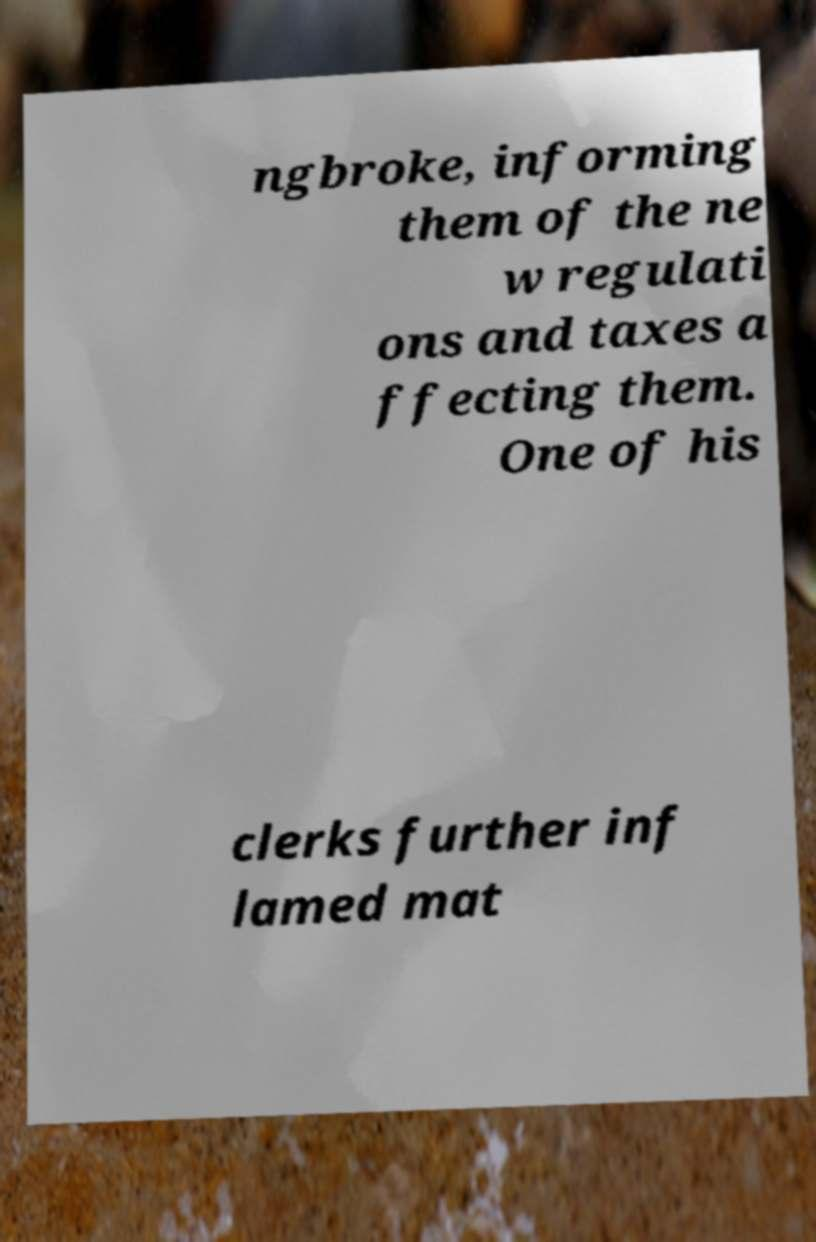What messages or text are displayed in this image? I need them in a readable, typed format. ngbroke, informing them of the ne w regulati ons and taxes a ffecting them. One of his clerks further inf lamed mat 